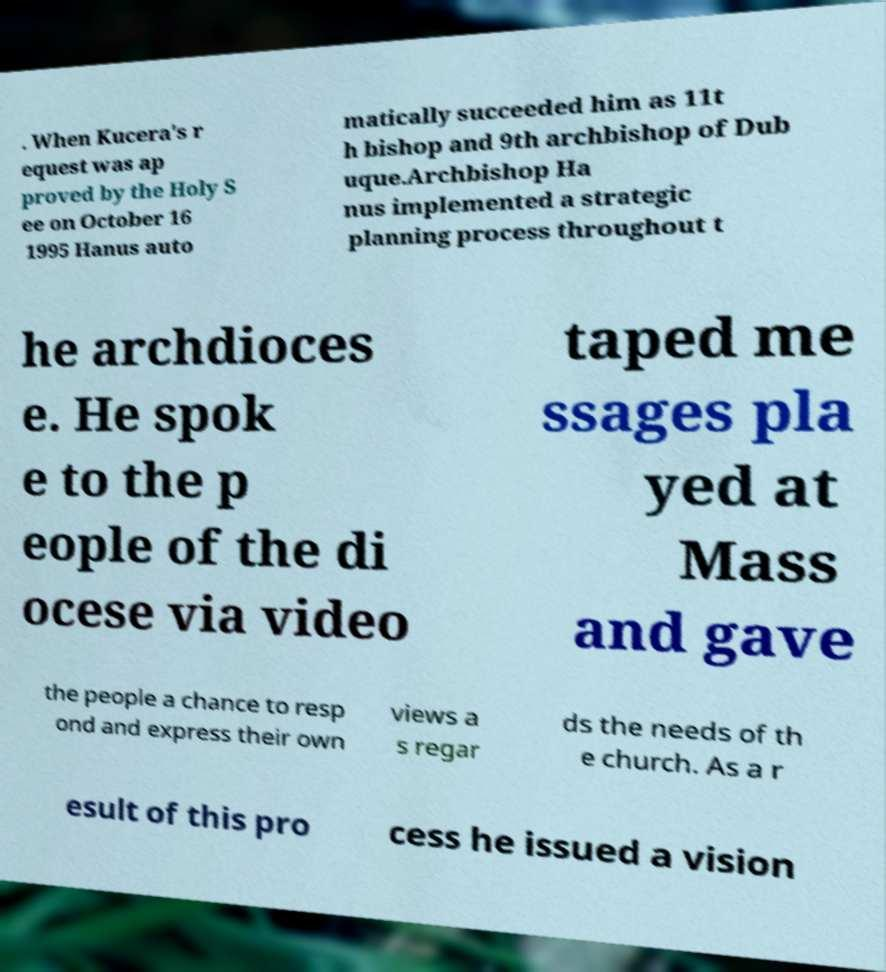For documentation purposes, I need the text within this image transcribed. Could you provide that? . When Kucera's r equest was ap proved by the Holy S ee on October 16 1995 Hanus auto matically succeeded him as 11t h bishop and 9th archbishop of Dub uque.Archbishop Ha nus implemented a strategic planning process throughout t he archdioces e. He spok e to the p eople of the di ocese via video taped me ssages pla yed at Mass and gave the people a chance to resp ond and express their own views a s regar ds the needs of th e church. As a r esult of this pro cess he issued a vision 